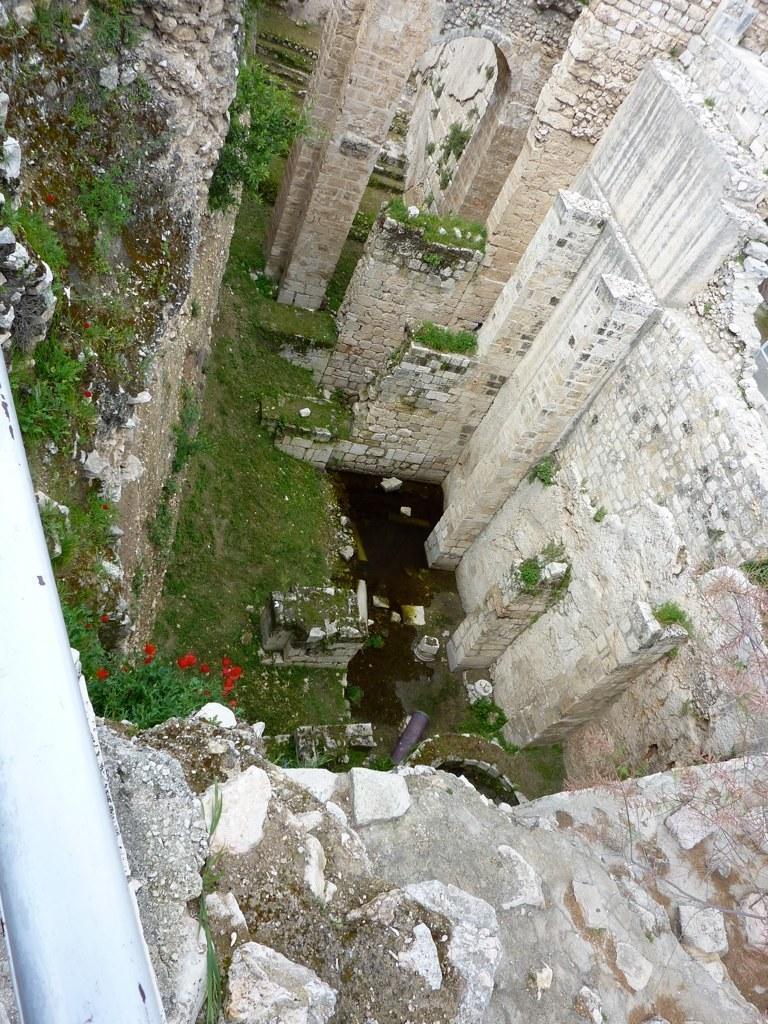Please provide a concise description of this image. In this image I can see few buildings in white and cream color, and I can also see flowers in red color and plants and grass in green color. 